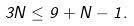Convert formula to latex. <formula><loc_0><loc_0><loc_500><loc_500>3 N \leq 9 + N - 1 .</formula> 